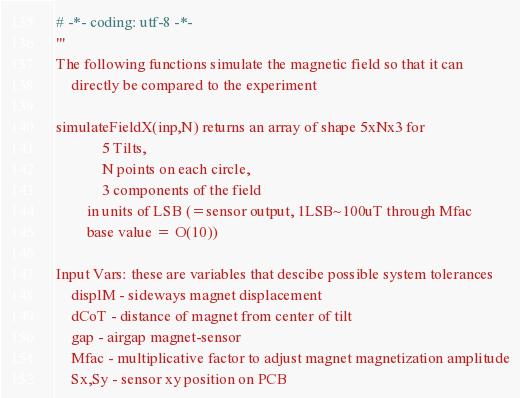Convert code to text. <code><loc_0><loc_0><loc_500><loc_500><_Python_># -*- coding: utf-8 -*-
'''
The following functions simulate the magnetic field so that it can
    directly be compared to the experiment

simulateFieldX(inp,N) returns an array of shape 5xNx3 for 
            5 Tilts, 
            N points on each circle, 
            3 components of the field
        in units of LSB (=sensor output, 1LSB~100uT through Mfac 
        base value = O(10))

Input Vars: these are variables that descibe possible system tolerances
    displM - sideways magnet displacement
    dCoT - distance of magnet from center of tilt
    gap - airgap magnet-sensor
    Mfac - multiplicative factor to adjust magnet magnetization amplitude
    Sx,Sy - sensor xy position on PCB</code> 